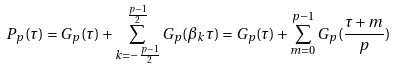<formula> <loc_0><loc_0><loc_500><loc_500>P _ { p } ( \tau ) = G _ { p } ( \tau ) + \sum _ { k = { - \frac { p - 1 } { 2 } } } ^ { \frac { p - 1 } { 2 } } G _ { p } ( \beta _ { k } \tau ) = G _ { p } ( \tau ) + \sum _ { m = 0 } ^ { p - 1 } G _ { p } ( \frac { \tau + m } { p } )</formula> 